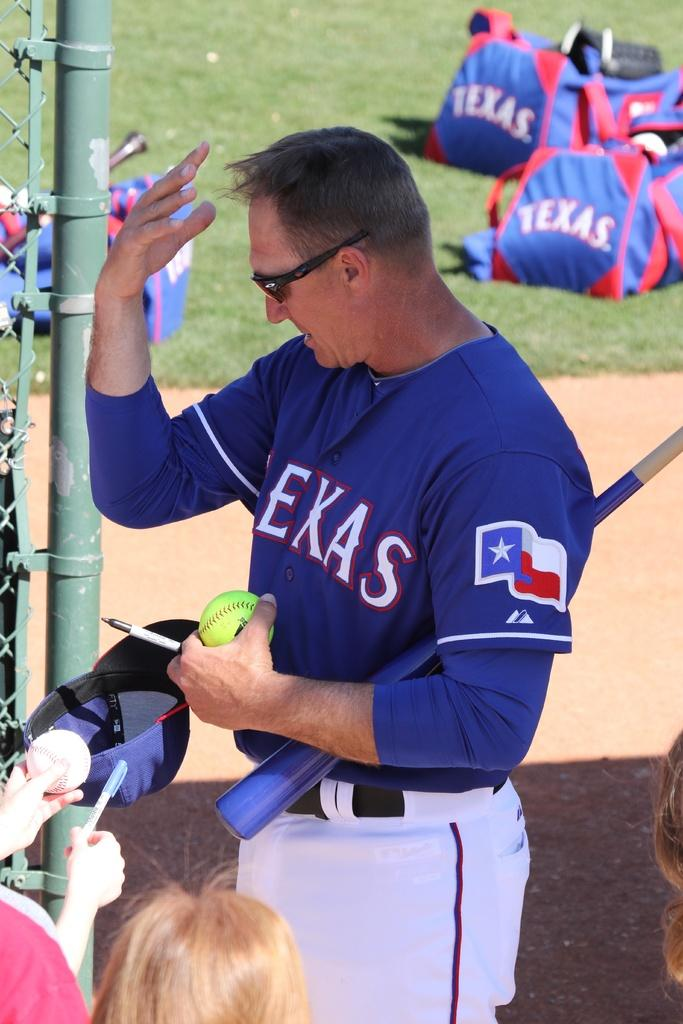<image>
Create a compact narrative representing the image presented. Texas baseball player has a ball and a pen in his hand and it looks like he is giving autographs for fans. 